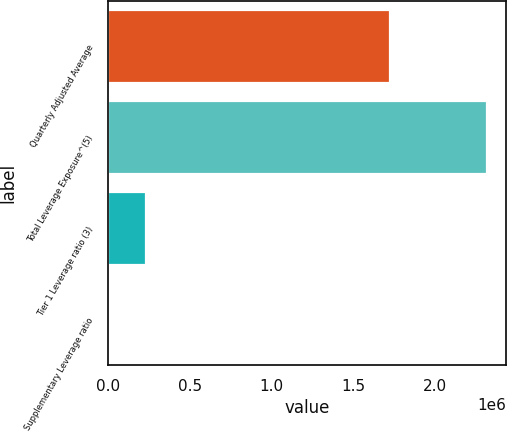Convert chart to OTSL. <chart><loc_0><loc_0><loc_500><loc_500><bar_chart><fcel>Quarterly Adjusted Average<fcel>Total Leverage Exposure^(5)<fcel>Tier 1 Leverage ratio (3)<fcel>Supplementary Leverage ratio<nl><fcel>1.72471e+06<fcel>2.31785e+06<fcel>231791<fcel>7.08<nl></chart> 